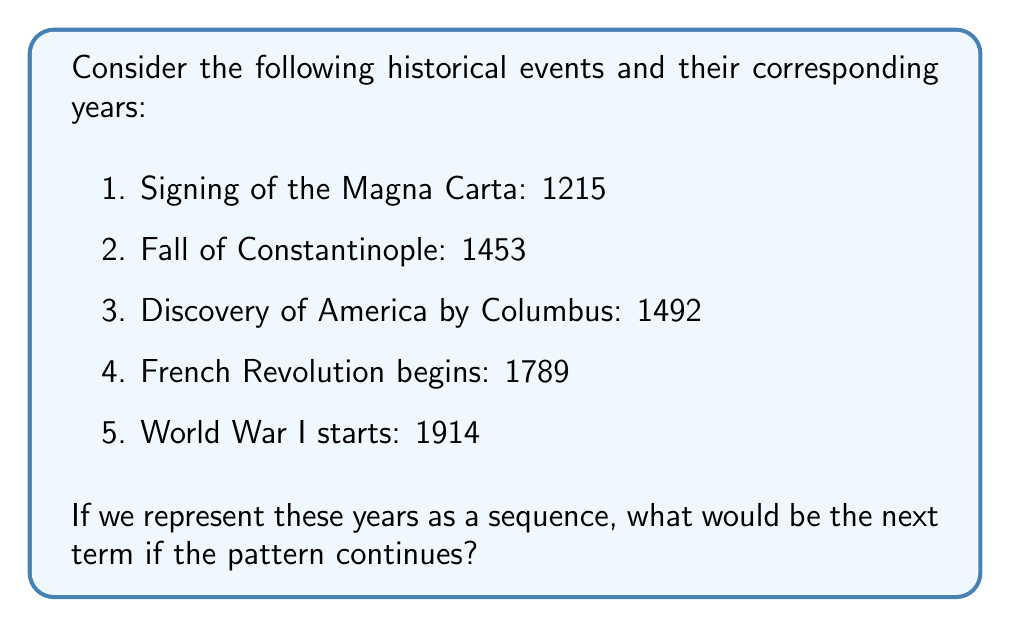Provide a solution to this math problem. To solve this problem, we need to analyze the pattern in the given sequence of years:

1215, 1453, 1492, 1789, 1914

Let's calculate the differences between consecutive terms:

1. $1453 - 1215 = 238$
2. $1492 - 1453 = 39$
3. $1789 - 1492 = 297$
4. $1914 - 1789 = 125$

At first glance, there doesn't seem to be a consistent pattern in these differences. However, as a history teacher, you might notice that these events are significant turning points in world history, often marking the end of one era and the beginning of another.

Let's consider the years as a mathematical sequence and try to find a pattern:

$$a_n = 1215 + 238 + 39 + 297 + 125 + ...$$

We can represent this as:

$$a_n = 1215 + \sum_{i=1}^{n-1} d_i$$

Where $d_i$ represents the difference between consecutive terms.

To find the next term, we need to determine $d_5$. Looking at the historical context, the next significant global event after World War I would likely be World War II, which started in 1939.

So, $d_5 = 1939 - 1914 = 25$

Therefore, the next term in the sequence would be:

$$a_6 = 1914 + 25 = 1939$$
Answer: 1939 